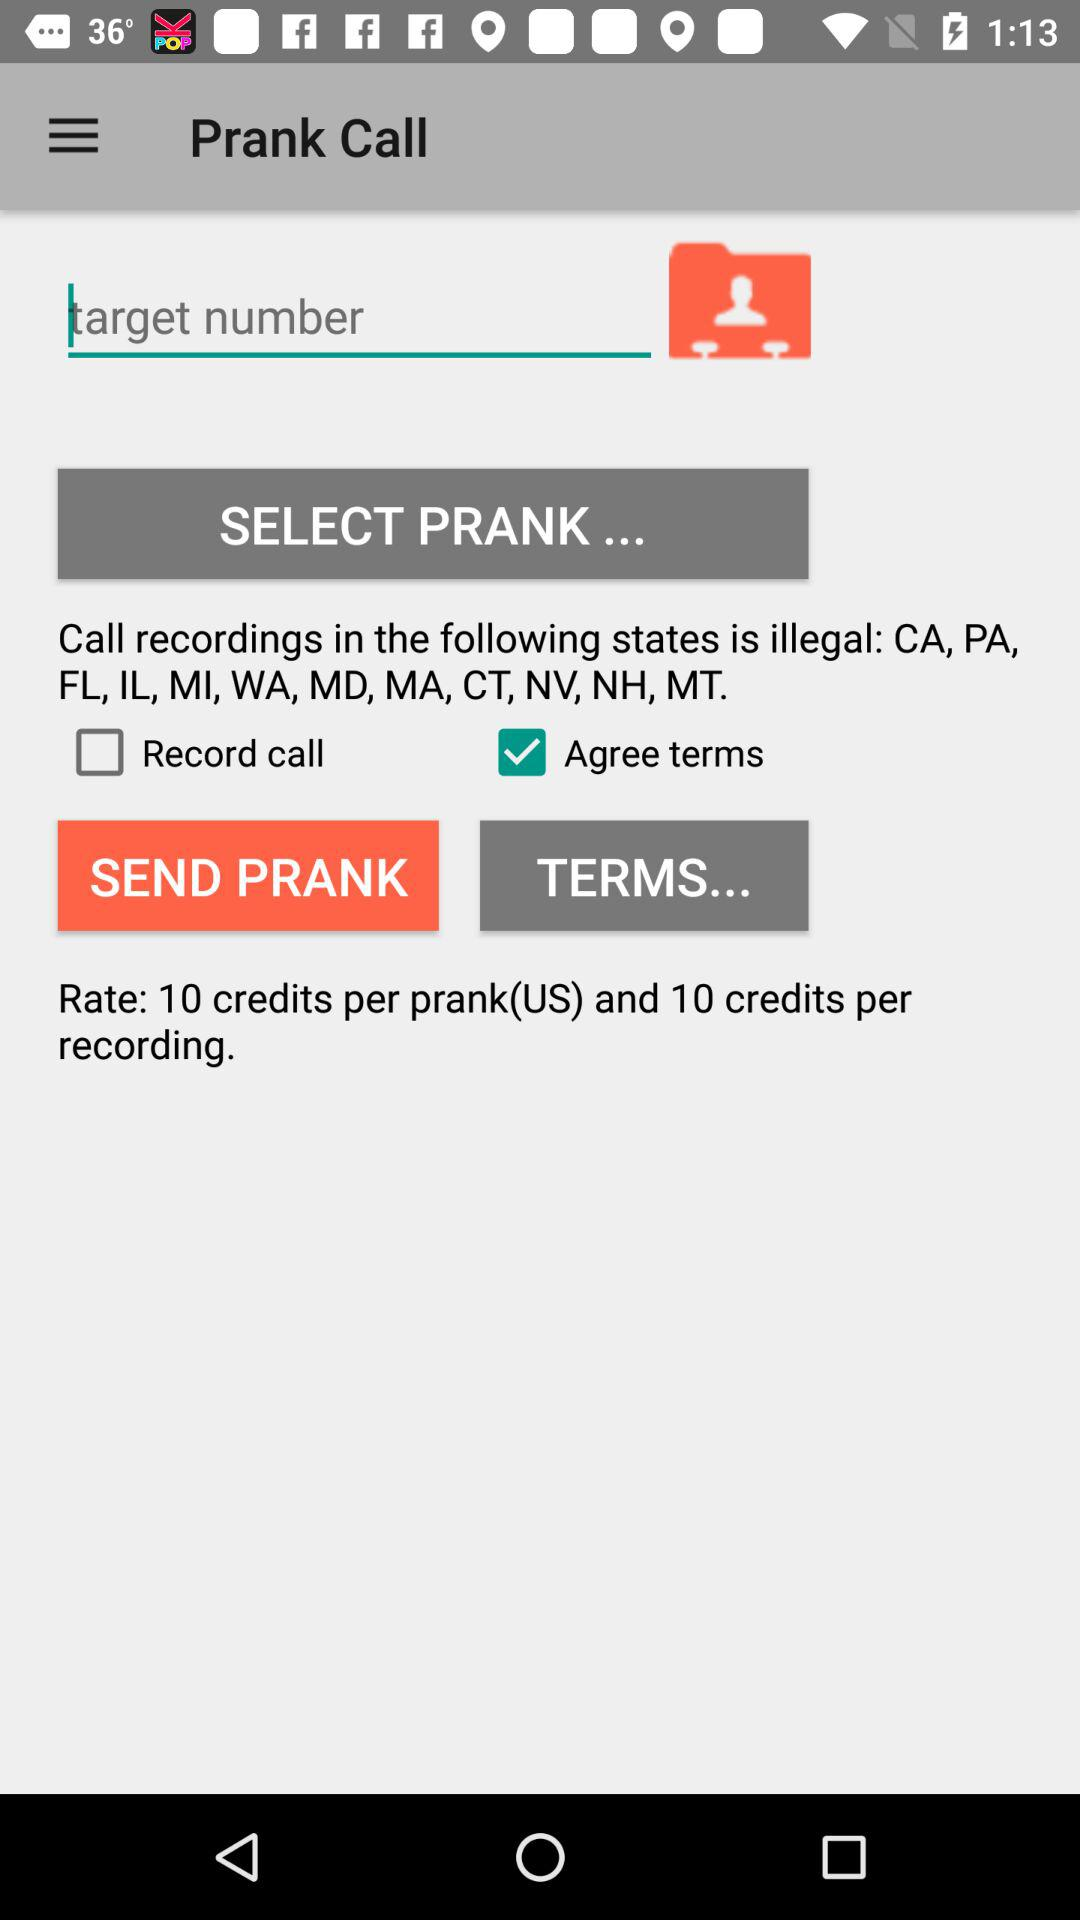What is the per-prank rate? The per-prank rate is 10 credits. 